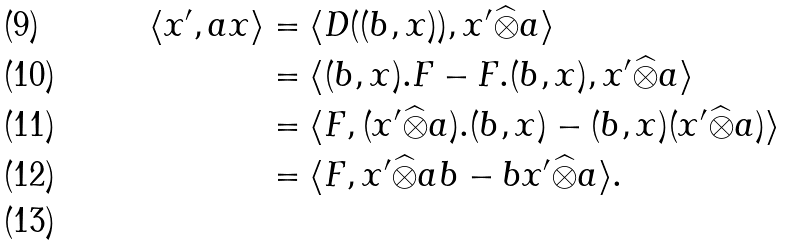Convert formula to latex. <formula><loc_0><loc_0><loc_500><loc_500>\langle x ^ { \prime } , a x \rangle & = \langle D ( ( b , x ) ) , x ^ { \prime } \widehat { \otimes } a \rangle \\ & = \langle ( b , x ) . F - F . ( b , x ) , x ^ { \prime } \widehat { \otimes } a \rangle \\ & = \langle F , ( x ^ { \prime } \widehat { \otimes } a ) . ( b , x ) - ( b , x ) ( x ^ { \prime } \widehat { \otimes } a ) \rangle \\ & = \langle F , x ^ { \prime } \widehat { \otimes } a b - b x ^ { \prime } \widehat { \otimes } a \rangle . \\</formula> 